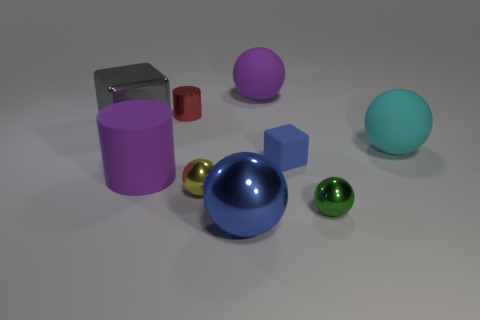Subtract all purple spheres. How many spheres are left? 4 Subtract all big purple rubber spheres. How many spheres are left? 4 Subtract all brown balls. Subtract all green blocks. How many balls are left? 5 Add 1 cyan metal blocks. How many objects exist? 10 Subtract all cylinders. How many objects are left? 7 Subtract all large cyan matte spheres. Subtract all purple objects. How many objects are left? 6 Add 5 tiny matte blocks. How many tiny matte blocks are left? 6 Add 2 big matte spheres. How many big matte spheres exist? 4 Subtract 1 blue cubes. How many objects are left? 8 